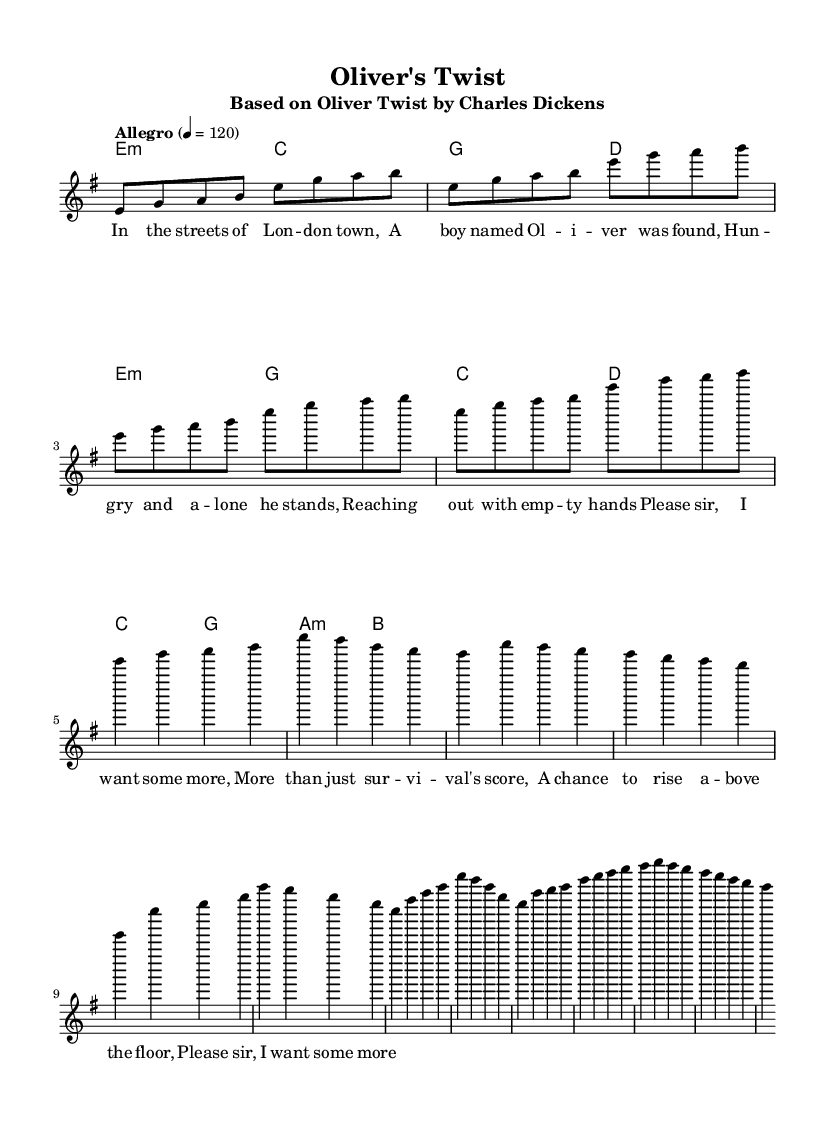What is the key signature of this music? The key signature is indicated at the beginning of the score. It shows that there are no sharps or flats, indicating the music is in E minor.
Answer: E minor What is the time signature of the piece? The time signature is indicated right after the key signature. It shows 4/4, which means there are four beats in a measure and the quarter note gets one beat.
Answer: 4/4 What is the tempo marking for this piece? The tempo marking "Allegro" appears at the beginning of the score and indicates the piece should be played at a lively and fast pace, specifically at a speed of 120 beats per minute.
Answer: Allegro What is the structure of the piece based on its sections? The sheet music has an "Intro," "Verse," "Chorus," and "Bridge." These are labeled within the music, indicating a typical song structure.
Answer: Intro, Verse, Chorus, Bridge How many measures are in the verse section? Counting the measures in the verse section, we see that there are four measures present. This can be determined by counting the bar lines in that section.
Answer: Four measures What are the main chords used in the chorus? In the chorus section, the main chords are E minor, G major, C major, and D major. These are shown in the chord mode section corresponding to the chorus melody.
Answer: E minor, G major, C major, D major 